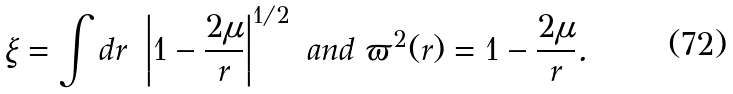Convert formula to latex. <formula><loc_0><loc_0><loc_500><loc_500>\xi = \int d r \ \left | 1 - \frac { 2 \mu } { r } \right | ^ { 1 / 2 } \ a n d \ \varpi ^ { 2 } ( r ) = 1 - \frac { 2 \mu } { r } .</formula> 